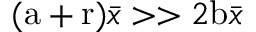<formula> <loc_0><loc_0><loc_500><loc_500>( a + r ) \bar { x } > > 2 b \bar { x }</formula> 